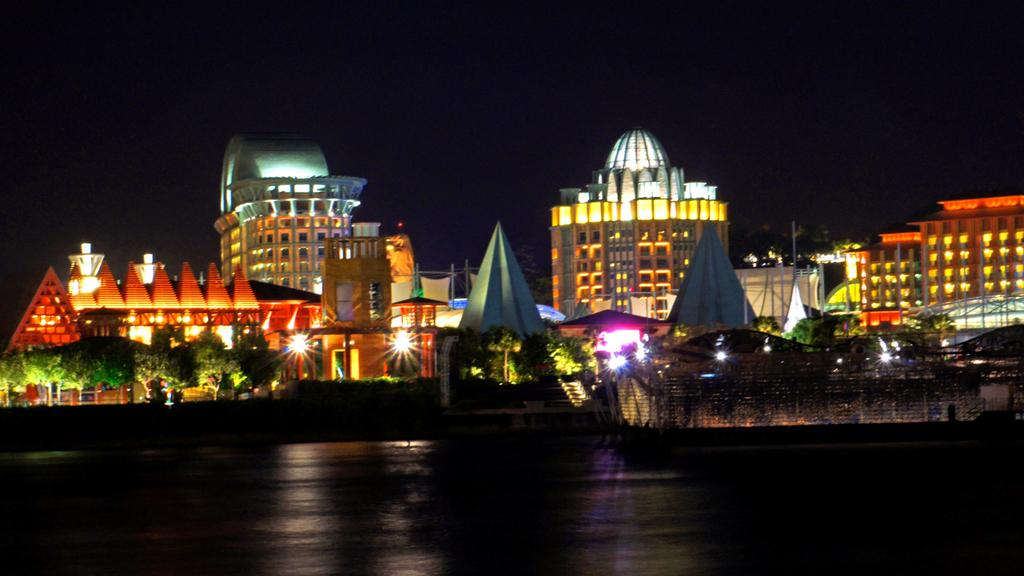What can be seen at the base of the image? The ground is visible in the image. What type of structures are present in the image? There are buildings in the image. What type of vegetation is present in the image? Trees are present in the image. What can be seen illuminating the image? Lights are visible in the image. What else can be seen in the image besides the ground, buildings, trees, and lights? There are objects in the image. How would you describe the overall appearance of the background in the image? The background of the image appears dark. Where is the scarecrow located in the image? There is no scarecrow present in the image. What type of bird can be seen perched on the crow in the image? There is no crow present in the image. 